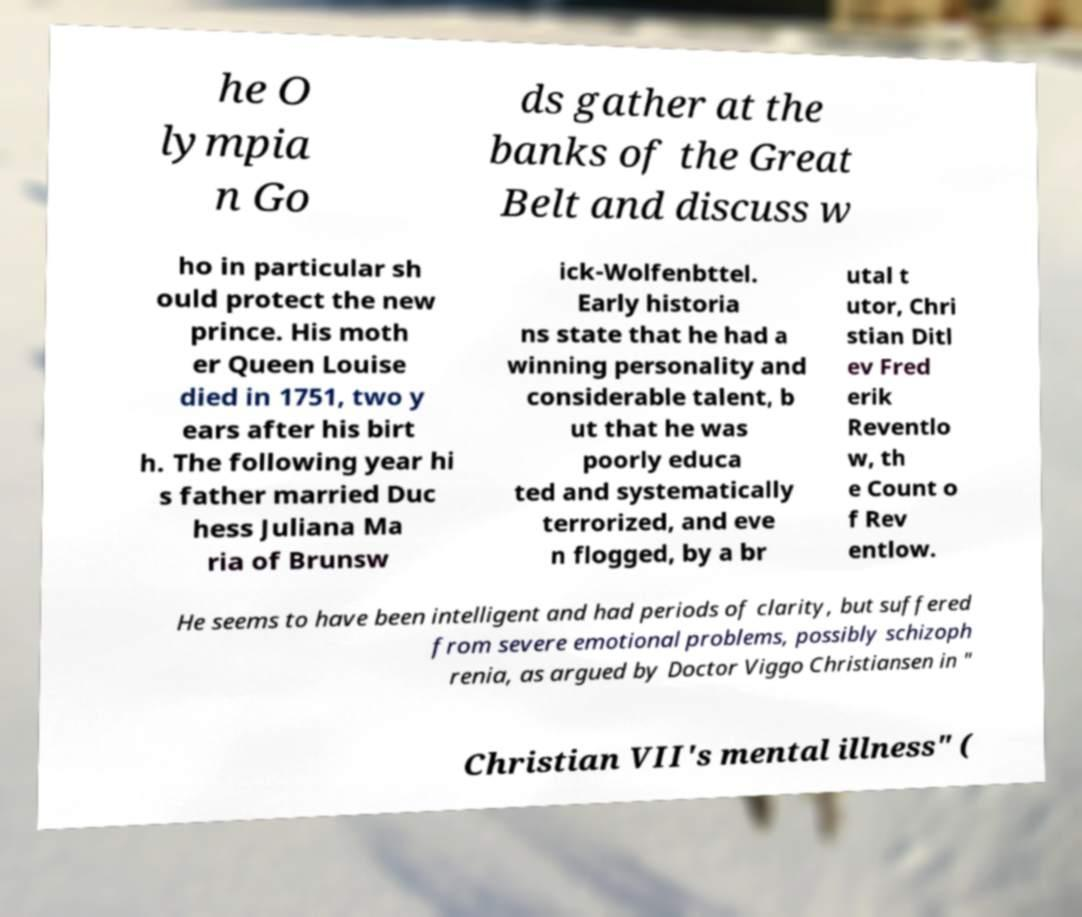I need the written content from this picture converted into text. Can you do that? he O lympia n Go ds gather at the banks of the Great Belt and discuss w ho in particular sh ould protect the new prince. His moth er Queen Louise died in 1751, two y ears after his birt h. The following year hi s father married Duc hess Juliana Ma ria of Brunsw ick-Wolfenbttel. Early historia ns state that he had a winning personality and considerable talent, b ut that he was poorly educa ted and systematically terrorized, and eve n flogged, by a br utal t utor, Chri stian Ditl ev Fred erik Reventlo w, th e Count o f Rev entlow. He seems to have been intelligent and had periods of clarity, but suffered from severe emotional problems, possibly schizoph renia, as argued by Doctor Viggo Christiansen in " Christian VII's mental illness" ( 